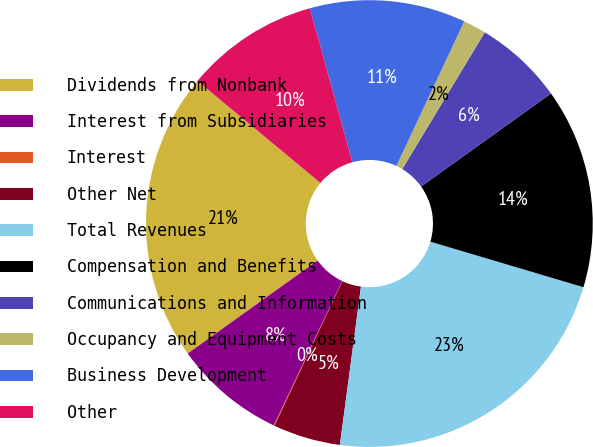Convert chart. <chart><loc_0><loc_0><loc_500><loc_500><pie_chart><fcel>Dividends from Nonbank<fcel>Interest from Subsidiaries<fcel>Interest<fcel>Other Net<fcel>Total Revenues<fcel>Compensation and Benefits<fcel>Communications and Information<fcel>Occupancy and Equipment Costs<fcel>Business Development<fcel>Other<nl><fcel>20.91%<fcel>8.08%<fcel>0.06%<fcel>4.87%<fcel>22.51%<fcel>14.49%<fcel>6.47%<fcel>1.66%<fcel>11.28%<fcel>9.68%<nl></chart> 